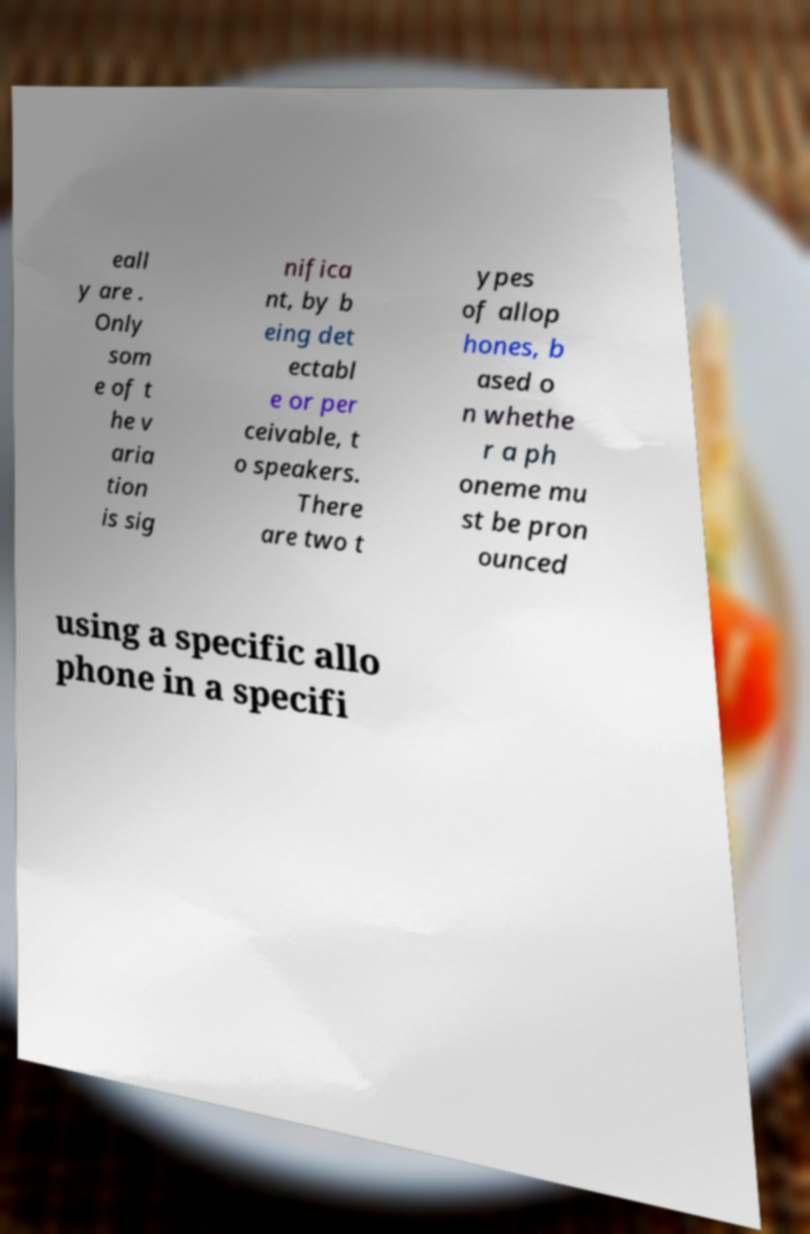What messages or text are displayed in this image? I need them in a readable, typed format. eall y are . Only som e of t he v aria tion is sig nifica nt, by b eing det ectabl e or per ceivable, t o speakers. There are two t ypes of allop hones, b ased o n whethe r a ph oneme mu st be pron ounced using a specific allo phone in a specifi 